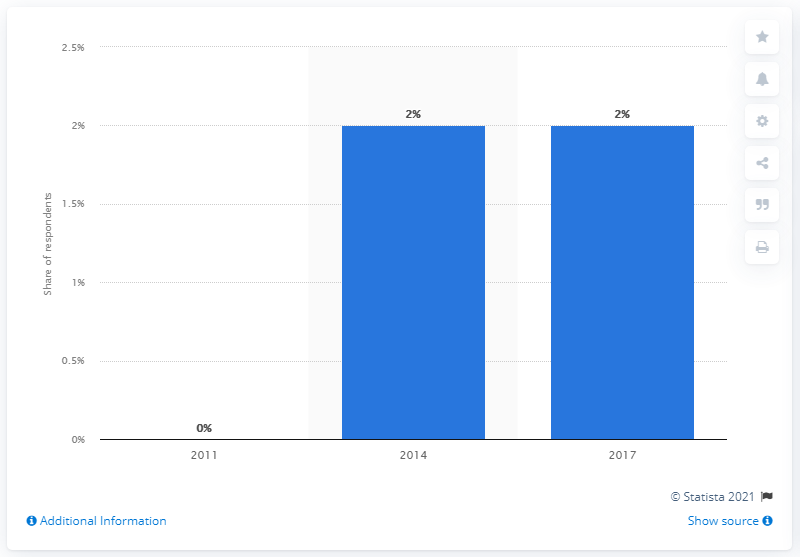Identify some key points in this picture. A survey about the ownership rate of credit cards in Indonesia was conducted in 2011. 